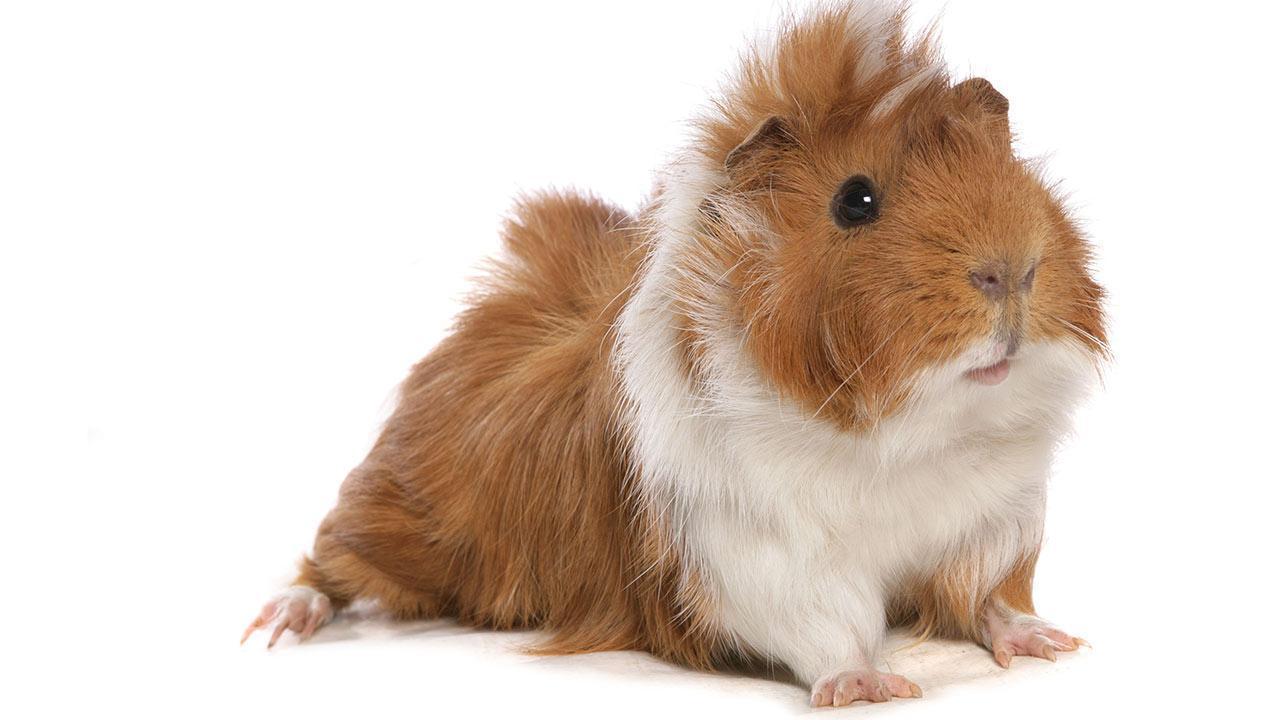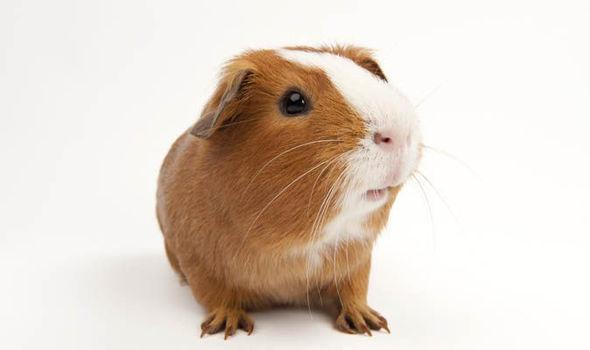The first image is the image on the left, the second image is the image on the right. Evaluate the accuracy of this statement regarding the images: "The right image contains at least twice as many guinea pigs as the left image.". Is it true? Answer yes or no. No. The first image is the image on the left, the second image is the image on the right. Considering the images on both sides, is "The right image contains at least two guinea pigs." valid? Answer yes or no. No. 